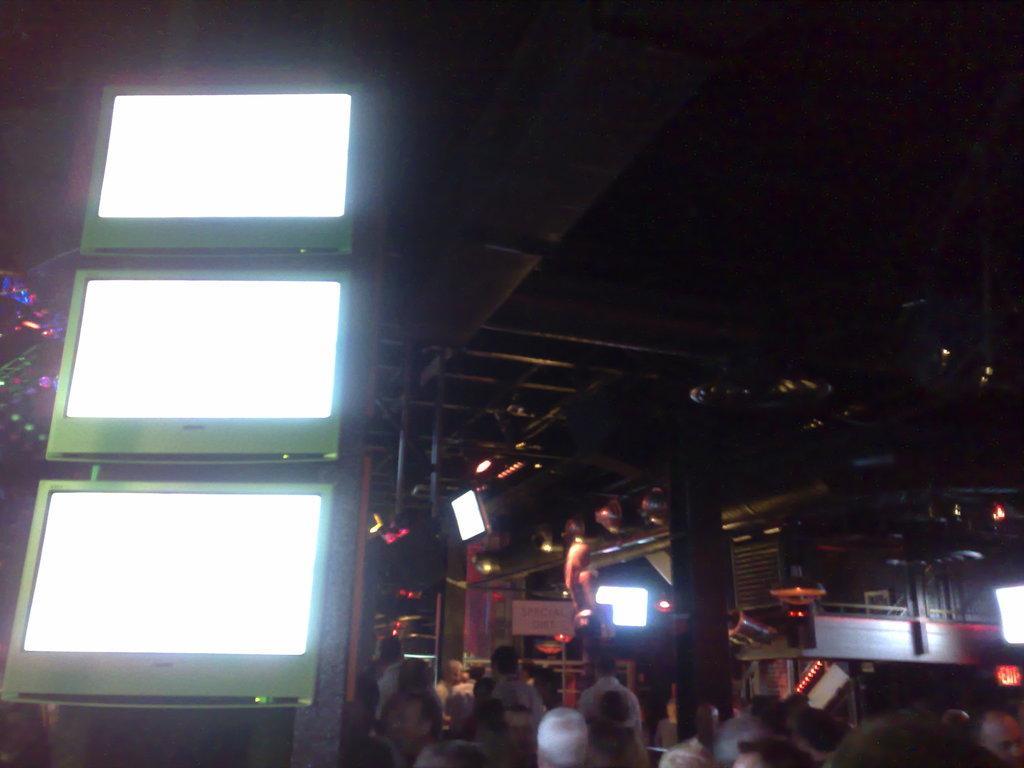How would you summarize this image in a sentence or two? In this image I can see few people, lights, few screens, iron poles and the image is dark. 